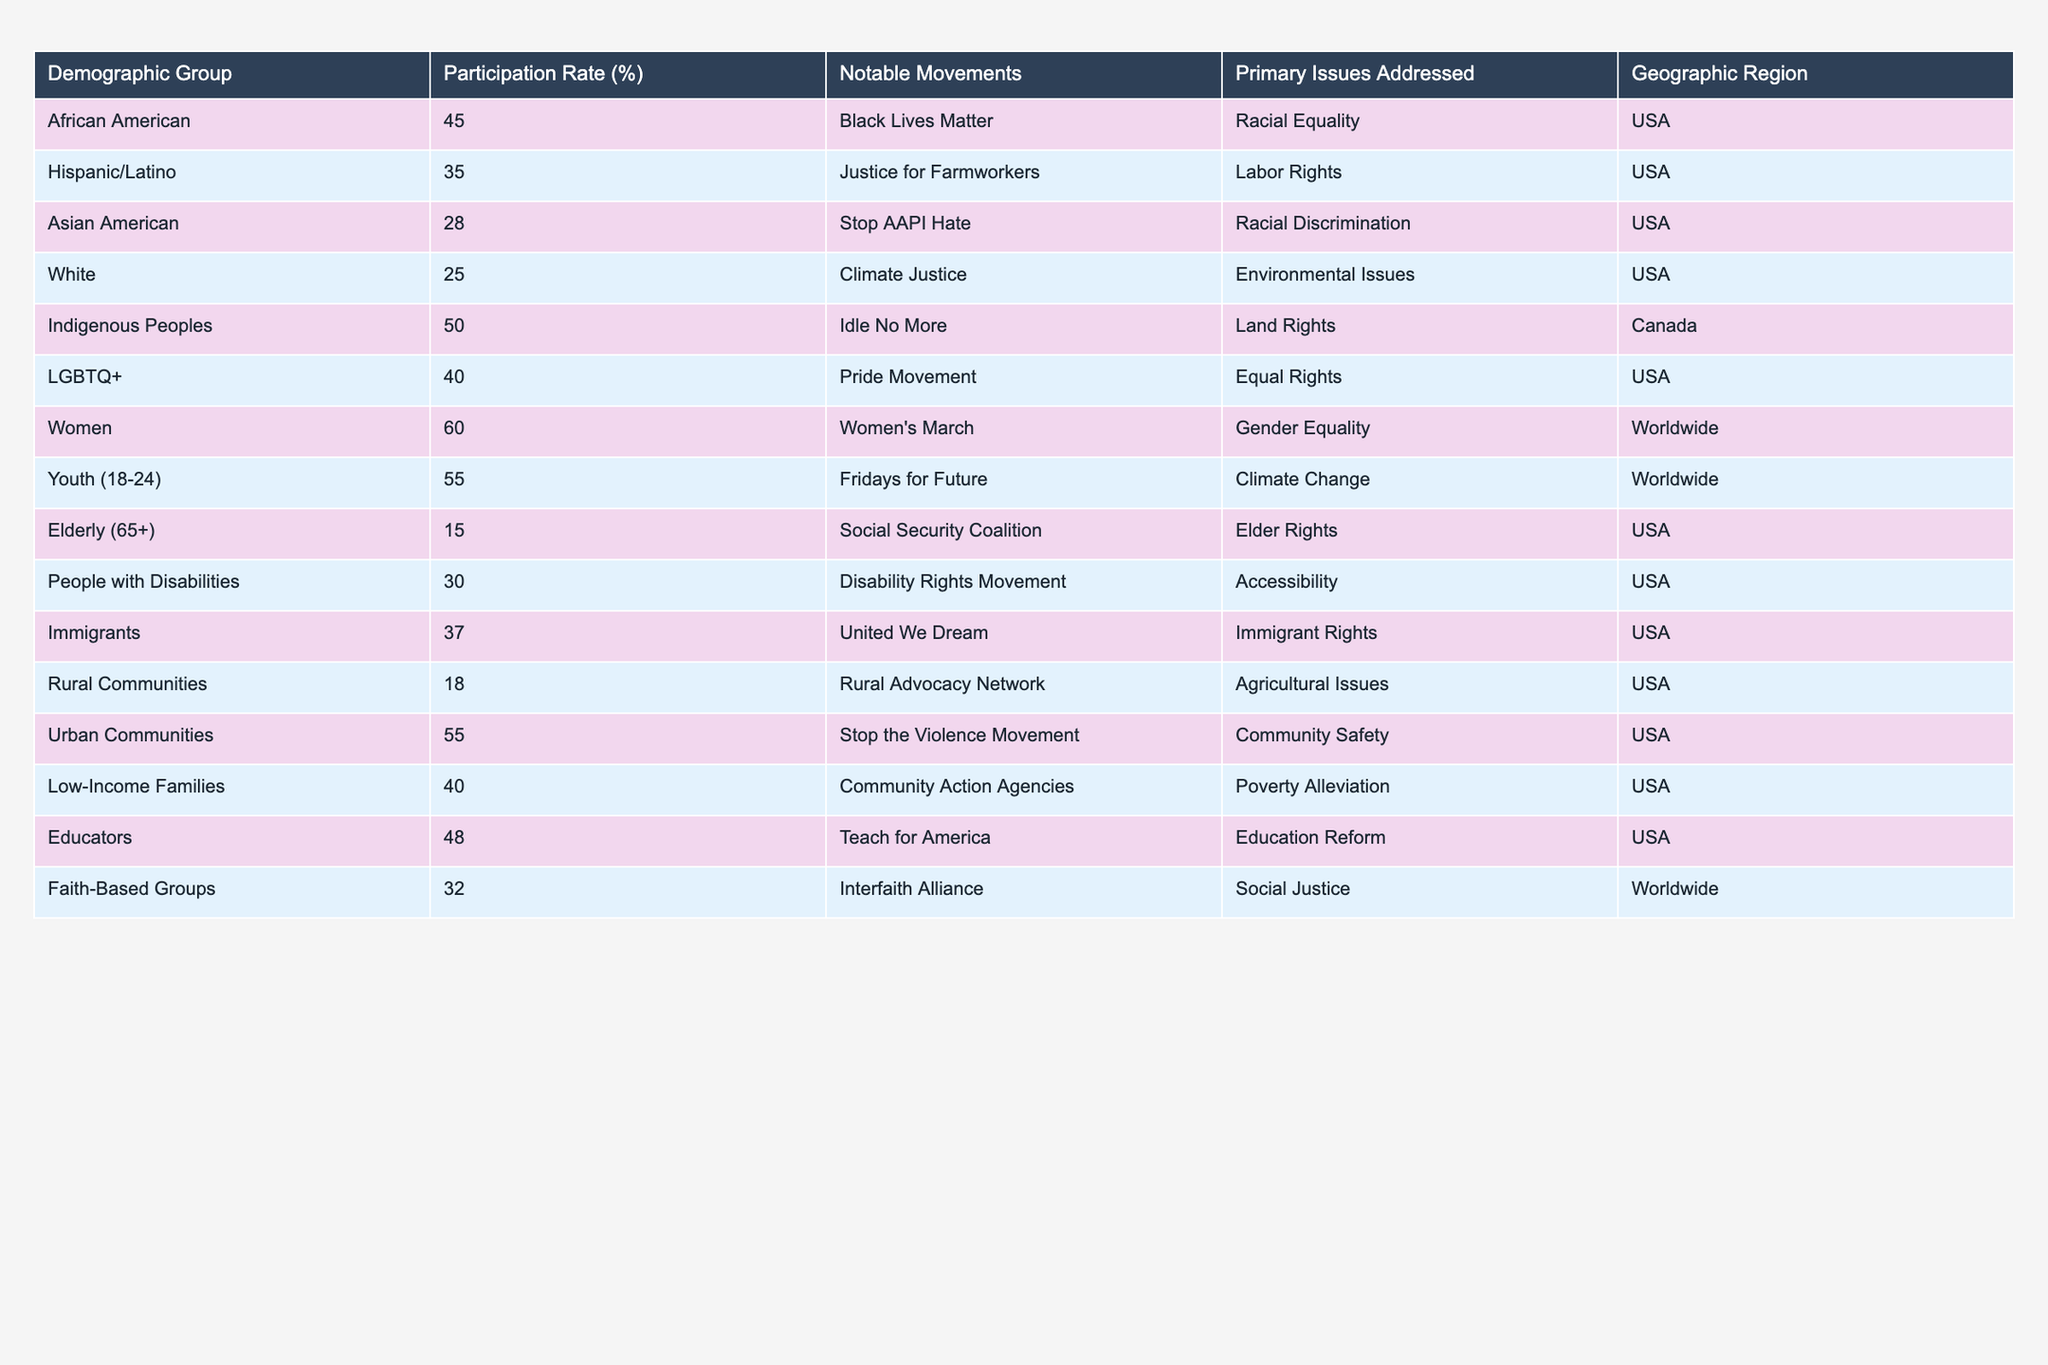What is the participation rate of Women in social justice movements? According to the table, the participation rate for Women is listed as 60%.
Answer: 60% What notable movement is associated with Indigenous Peoples? The table indicates that Indigenous Peoples are notably associated with the Idle No More movement.
Answer: Idle No More Which demographic group has the lowest participation rate? From the table, the Elderly (65+) demographic has the lowest participation rate at 15%.
Answer: 15% What is the average participation rate of the two groups with the highest participation rates? The highest participation rates are Women (60%) and Indigenous Peoples (50%). Adding them gives 110%, and dividing by 2 for the average results in 55%.
Answer: 55% Is it true that all demographic groups have a participation rate above 20%? Checking the table, the Rural Communities group has a participation rate of 18%, which is below 20%. Thus, the statement is false.
Answer: No What primary issue is addressed by the LGBTQ+ demographic? According to the table, the primary issue for the LGBTQ+ demographic is Equal Rights.
Answer: Equal Rights Which demographic has a higher participation rate, Hispanic/Latino or Asian American? The table lists the Hispanic/Latino participation rate as 35% and the Asian American rate as 28%. Since 35% is greater than 28%, Hispanic/Latino has a higher participation rate.
Answer: Hispanic/Latino What is the participation rate difference between Urban Communities and Low-Income Families? The participation rate for Urban Communities is 55% and for Low-Income Families is 40%. The difference is calculated as 55% - 40% = 15%.
Answer: 15% List all notable movements for demographic groups with participation rates over 40%. The groups with participation rates over 40% are African American (Black Lives Matter), Indigenous Peoples (Idle No More), Women (Women's March), Youth (Fridays for Future), Urban Communities (Stop the Violence Movement), and Low-Income Families (Community Action Agencies). So the notable movements are: Black Lives Matter, Idle No More, Women's March, Fridays for Future, Stop the Violence Movement, Community Action Agencies.
Answer: Black Lives Matter, Idle No More, Women's March, Fridays for Future, Stop the Violence Movement, Community Action Agencies Which geographic region has the highest participation rate among demographics? The table shows that Indigenous Peoples in Canada have the highest participation rate at 50%.
Answer: Canada What percentage of People with Disabilities participated in social justice movements? The table shows that People with Disabilities have a participation rate of 30%.
Answer: 30% 